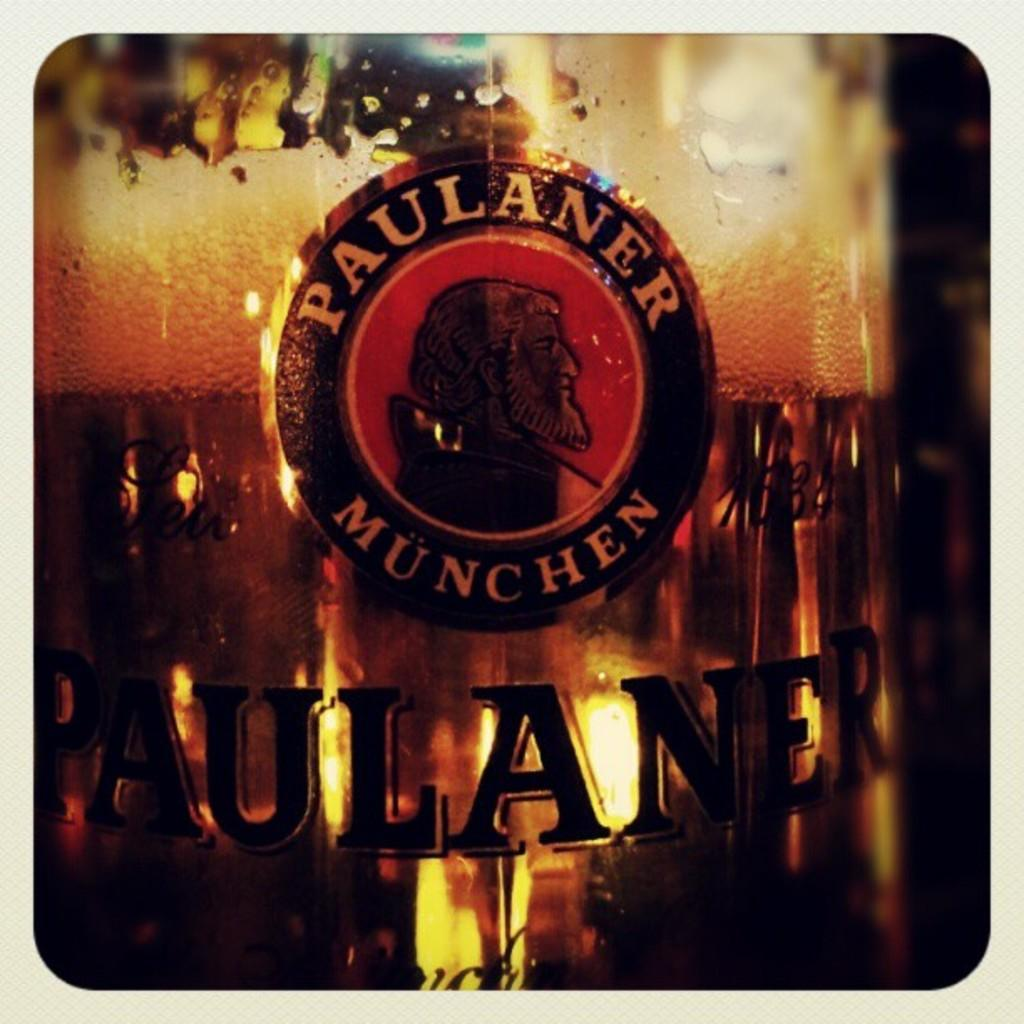Provide a one-sentence caption for the provided image. A picture of the trademark of a beer called Paulaner Munchen. 